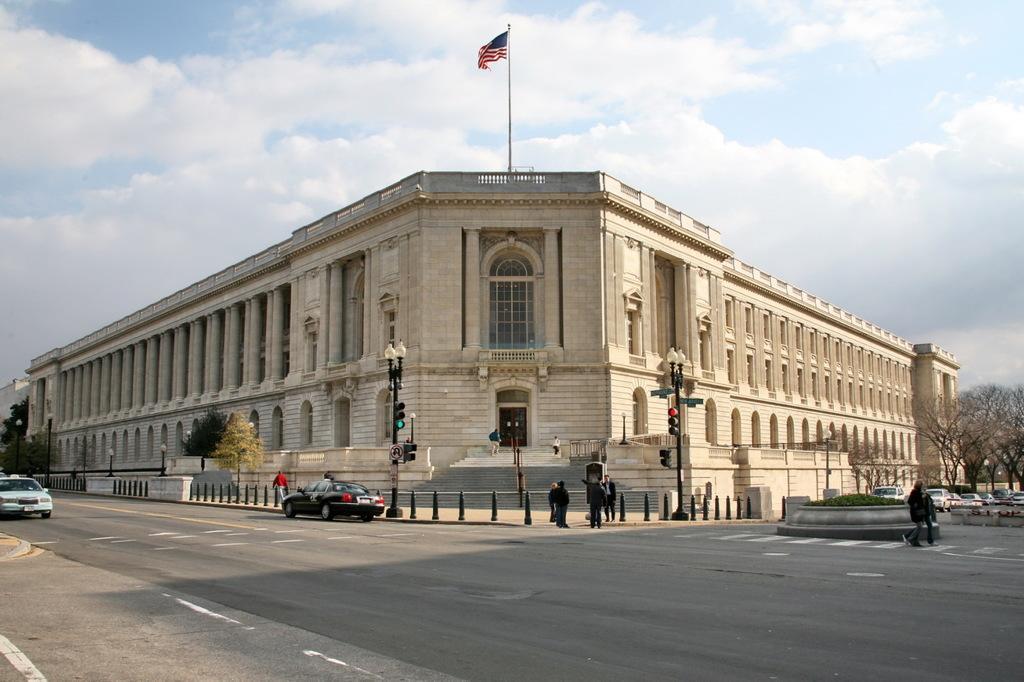Can you describe this image briefly? In the image in the center we can see few vehicles on the road. And we can see few people were standing. In the background we can see the sky,clouds,trees,buildings,pillars,poles,wall,staircase,road etc. 